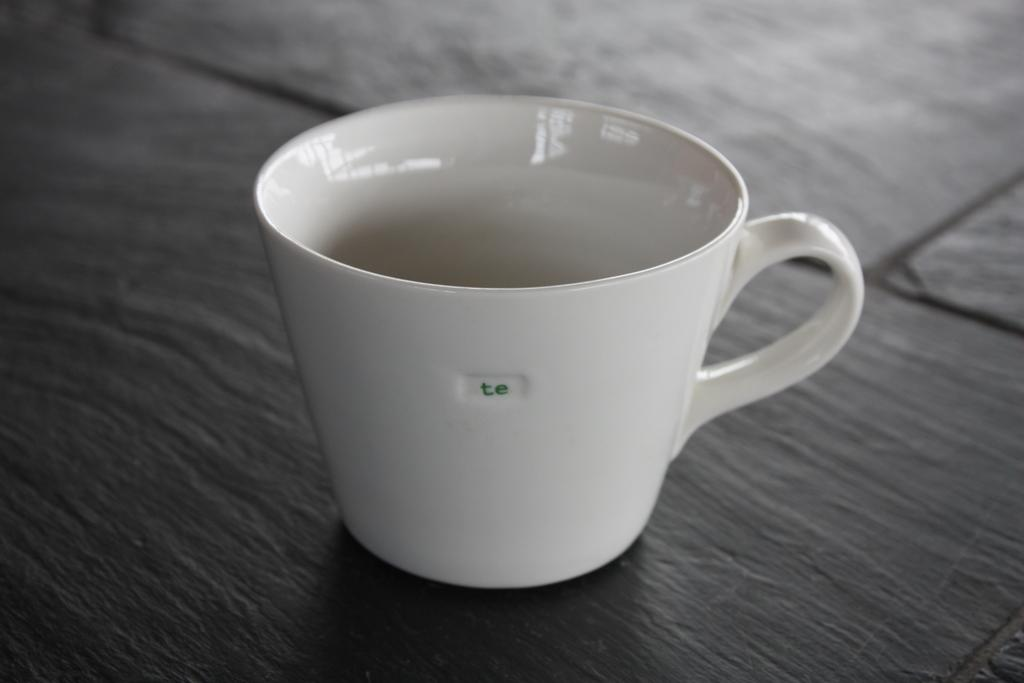<image>
Summarize the visual content of the image. A white teacup with the letters te on it is on a dark surface. 